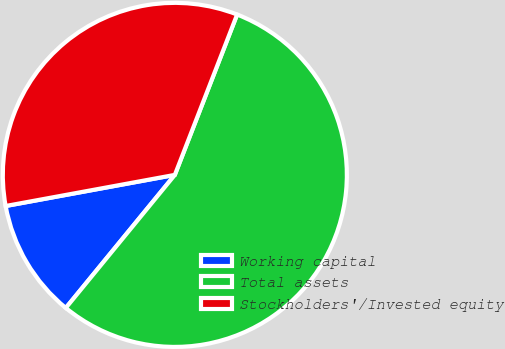Convert chart to OTSL. <chart><loc_0><loc_0><loc_500><loc_500><pie_chart><fcel>Working capital<fcel>Total assets<fcel>Stockholders'/Invested equity<nl><fcel>11.18%<fcel>55.03%<fcel>33.79%<nl></chart> 